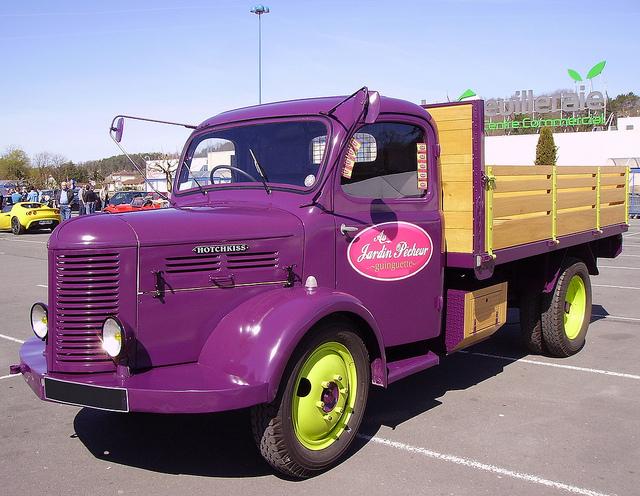What colors are the wheel caps?
Short answer required. Yellow. What is the truck towing?
Write a very short answer. Nothing. What company owns this truck?
Keep it brief. Jordan picker. 